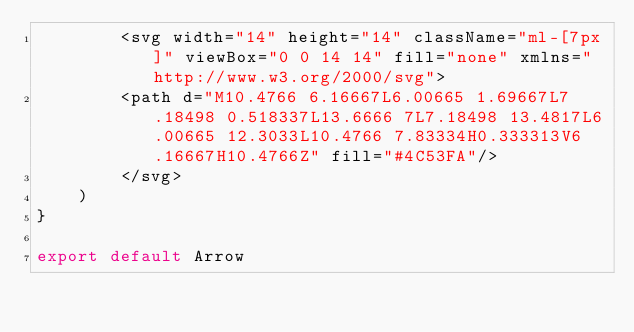Convert code to text. <code><loc_0><loc_0><loc_500><loc_500><_JavaScript_>        <svg width="14" height="14" className="ml-[7px]" viewBox="0 0 14 14" fill="none" xmlns="http://www.w3.org/2000/svg">
        <path d="M10.4766 6.16667L6.00665 1.69667L7.18498 0.518337L13.6666 7L7.18498 13.4817L6.00665 12.3033L10.4766 7.83334H0.333313V6.16667H10.4766Z" fill="#4C53FA"/>
        </svg>
    )
}

export default Arrow
</code> 